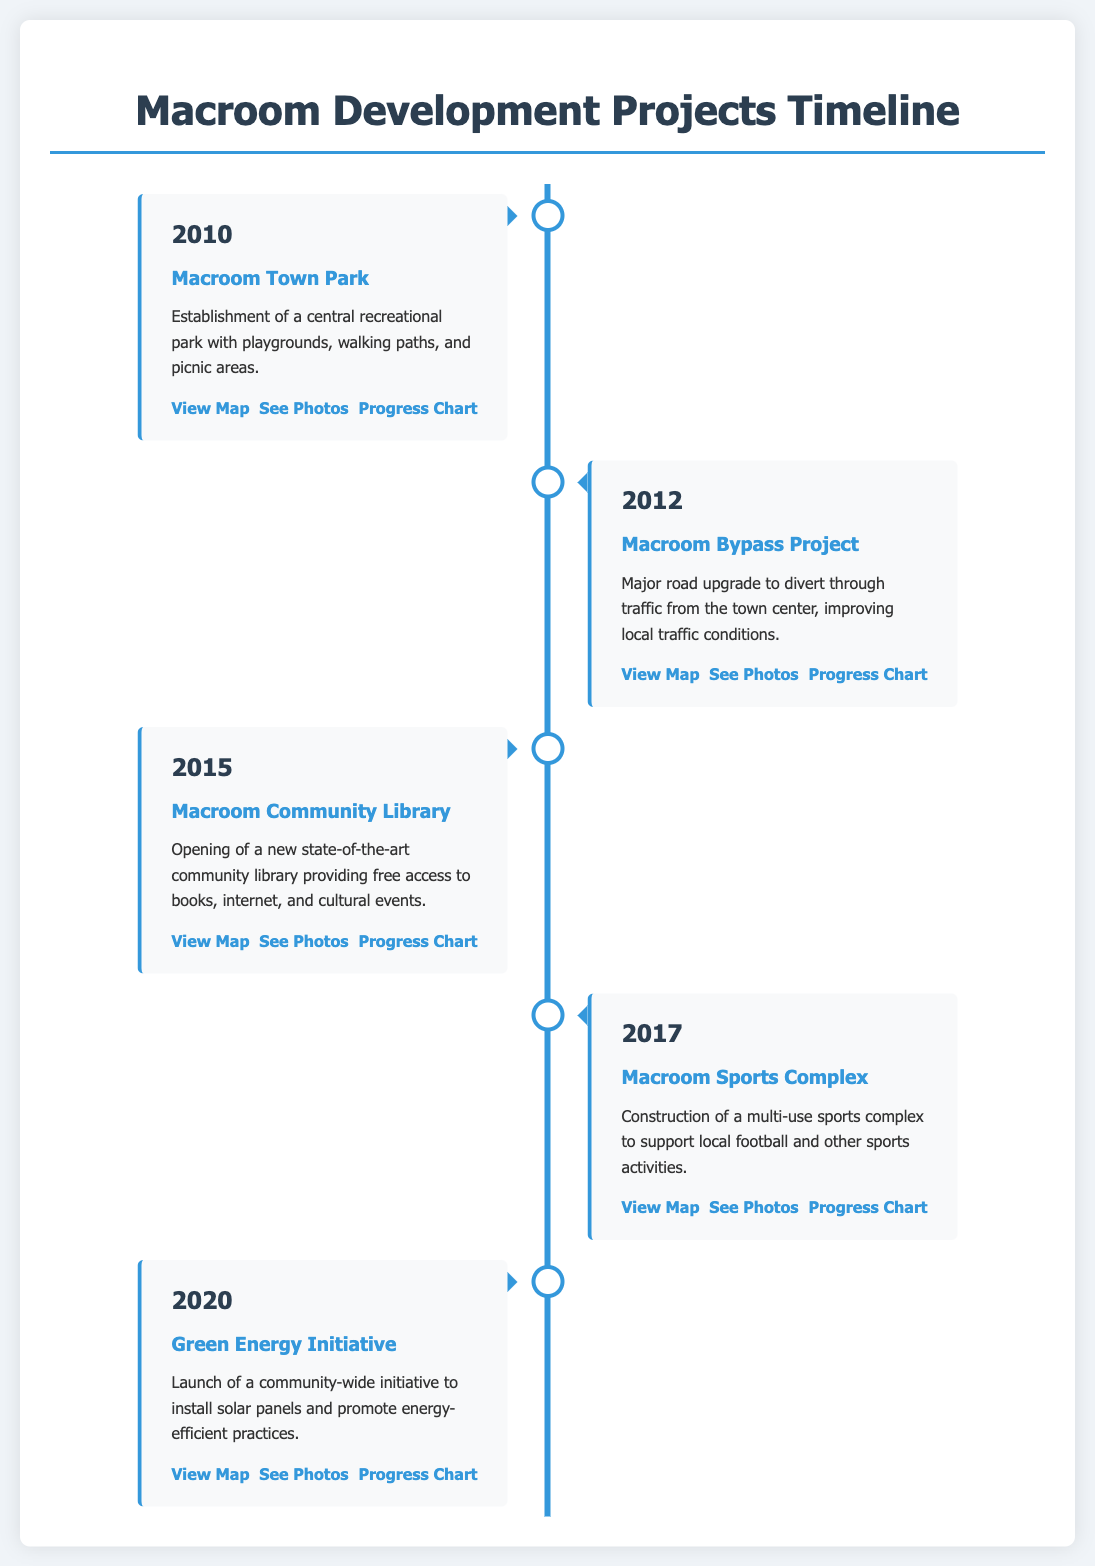What year was the Macroom Town Park established? The year mentioned for the establishment of Macroom Town Park in the timeline is 2010.
Answer: 2010 What project was completed in 2015? In 2015, the new state-of-the-art community library was opened as noted in the timeline.
Answer: Macroom Community Library What is the primary purpose of the Macroom Sports Complex? The document states that the Macroom Sports Complex was constructed to support local football and other sports activities.
Answer: Multi-use sports complex How many major infrastructure developments are listed in the timeline? The document outlines five significant infrastructure developments in Macroom Township.
Answer: Five What community initiative was launched in 2020? The timeline mentions the Green Energy Initiative, a community-wide initiative launched in 2020.
Answer: Green Energy Initiative Which project involved a major road upgrade? The Macroom Bypass Project is specifically identified as a major road upgrade in the timeline.
Answer: Macroom Bypass Project What type of map links are provided for each project? Each project includes links to view maps, see photos, and access progress charts, as highlighted throughout the timeline.
Answer: View Map In which year did the Macroom Community Library open? According to the timeline, the Macroom Community Library opened in 2015.
Answer: 2015 What key feature does the Macroom Town Park provide? The description lists playgrounds, walking paths, and picnic areas as key features of the Macroom Town Park.
Answer: Recreational park 